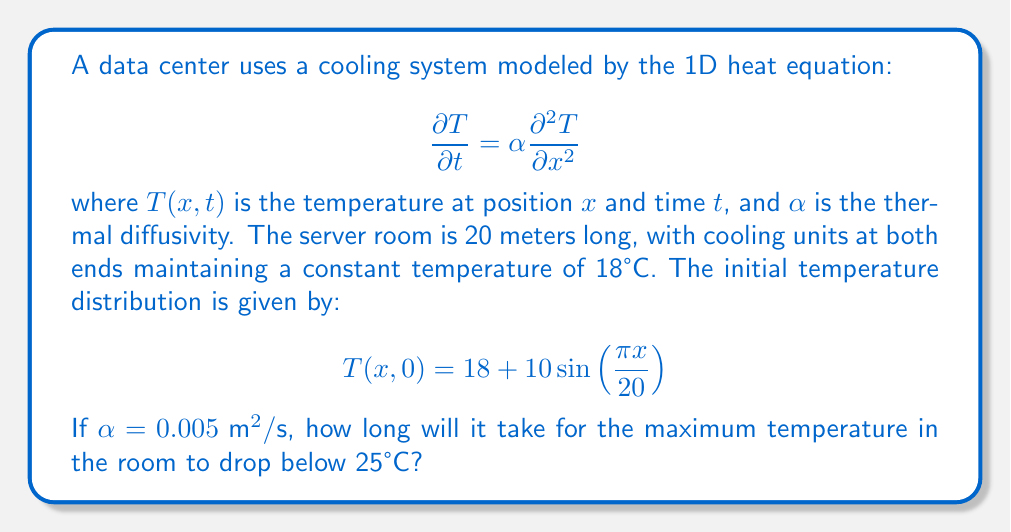Show me your answer to this math problem. To solve this problem, we need to use the separation of variables method for the heat equation:

1) The general solution for this problem is:

   $$T(x,t) = 18 + \sum_{n=1}^{\infty} B_n \sin(\frac{n\pi x}{20}) e^{-\alpha(\frac{n\pi}{20})^2 t}$$

2) Given the initial condition, we can see that only the first term ($n=1$) is non-zero:

   $$T(x,0) = 18 + 10 \sin(\frac{\pi x}{20})$$

3) Therefore, our solution simplifies to:

   $$T(x,t) = 18 + 10 \sin(\frac{\pi x}{20}) e^{-\alpha(\frac{\pi}{20})^2 t}$$

4) The maximum temperature occurs at $x = 10$ (middle of the room):

   $$T_{max}(t) = 18 + 10 e^{-\alpha(\frac{\pi}{20})^2 t}$$

5) We want to find $t$ when $T_{max}(t) = 25°C$:

   $$25 = 18 + 10 e^{-\alpha(\frac{\pi}{20})^2 t}$$

6) Solving for $t$:

   $$7 = 10 e^{-\alpha(\frac{\pi}{20})^2 t}$$
   $$0.7 = e^{-\alpha(\frac{\pi}{20})^2 t}$$
   $$\ln(0.7) = -\alpha(\frac{\pi}{20})^2 t$$
   $$t = -\frac{\ln(0.7)}{\alpha(\frac{\pi}{20})^2}$$

7) Substituting $\alpha = 0.005 \text{ m}^2/\text{s}$:

   $$t = -\frac{\ln(0.7)}{0.005(\frac{\pi}{20})^2} \approx 1416.8 \text{ seconds}$$
Answer: 1416.8 seconds 